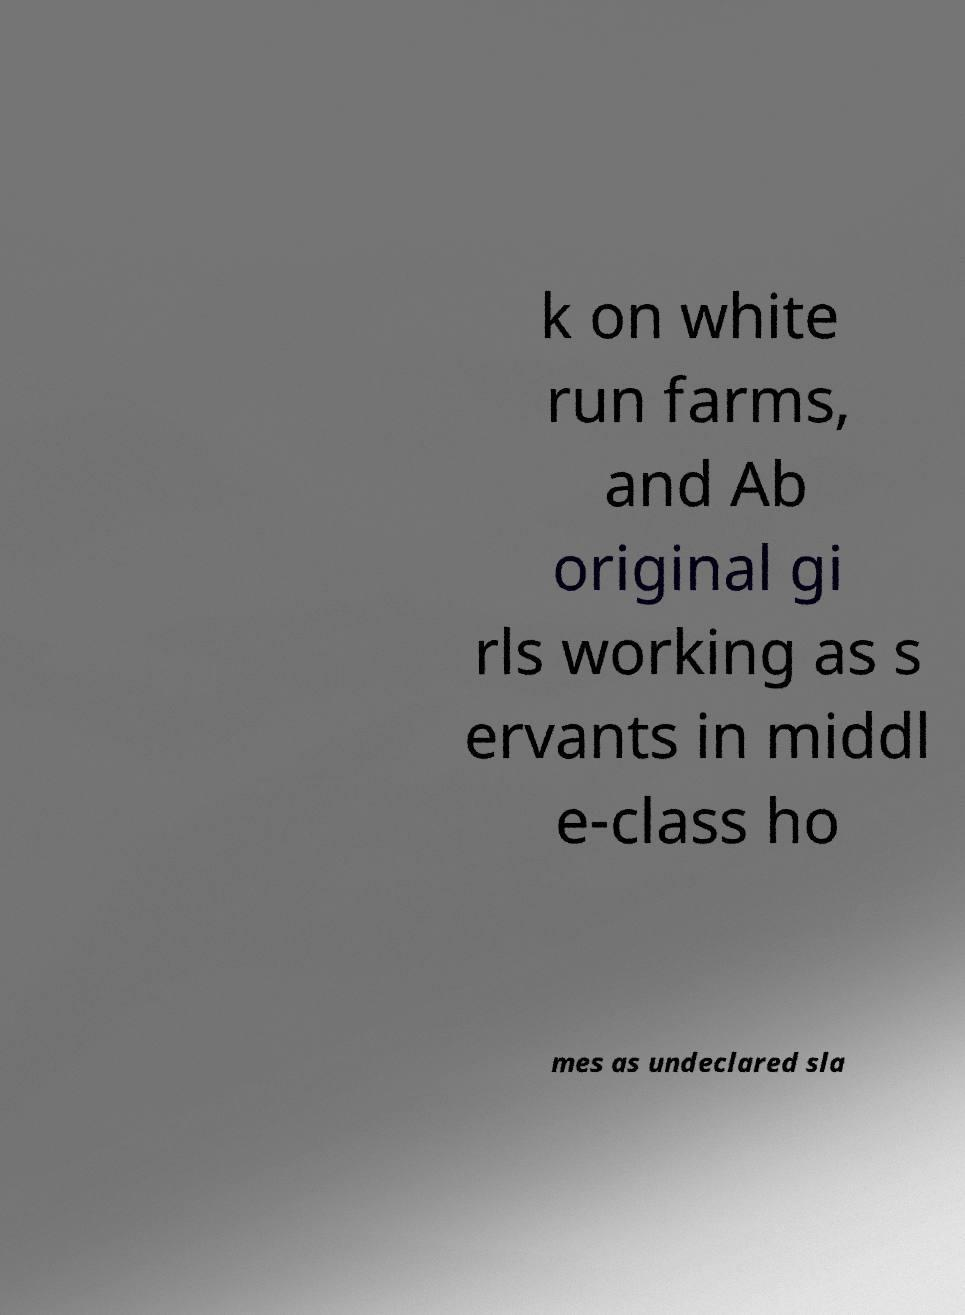Can you read and provide the text displayed in the image?This photo seems to have some interesting text. Can you extract and type it out for me? k on white run farms, and Ab original gi rls working as s ervants in middl e-class ho mes as undeclared sla 